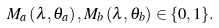Convert formula to latex. <formula><loc_0><loc_0><loc_500><loc_500>M _ { a } \left ( \lambda , \theta _ { a } \right ) , M _ { b } \left ( \lambda , \theta _ { b } \right ) \in \{ 0 , 1 \} .</formula> 